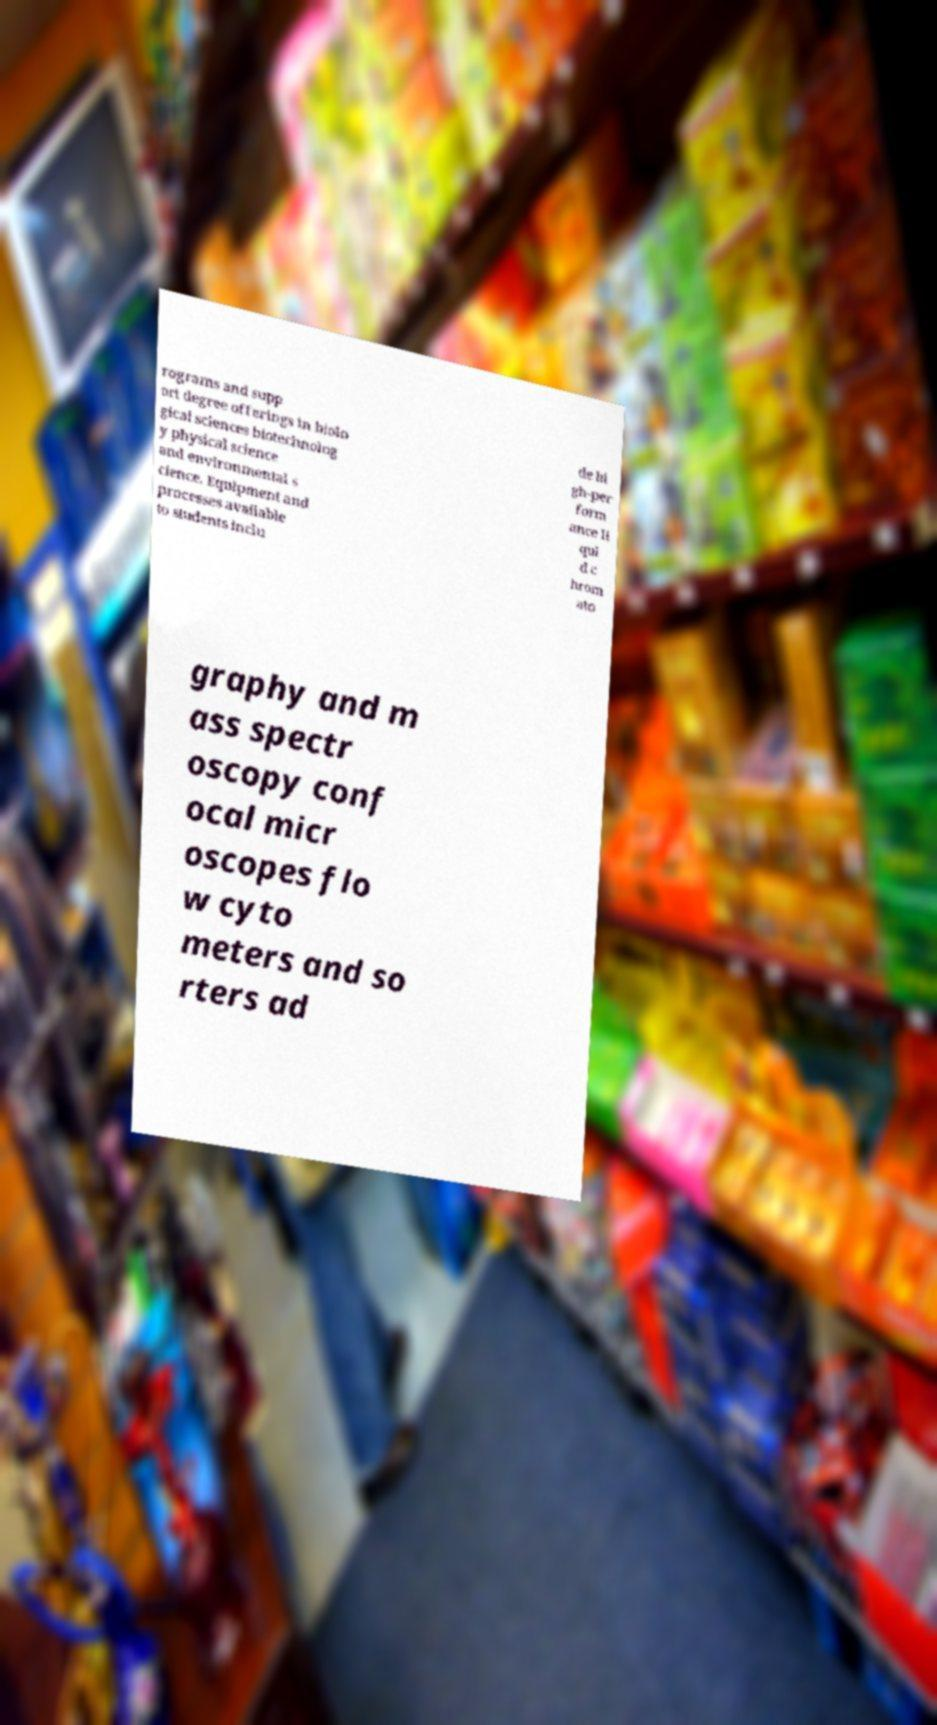Can you read and provide the text displayed in the image?This photo seems to have some interesting text. Can you extract and type it out for me? rograms and supp ort degree offerings in biolo gical sciences biotechnolog y physical science and environmental s cience. Equipment and processes available to students inclu de hi gh-per form ance li qui d c hrom ato graphy and m ass spectr oscopy conf ocal micr oscopes flo w cyto meters and so rters ad 